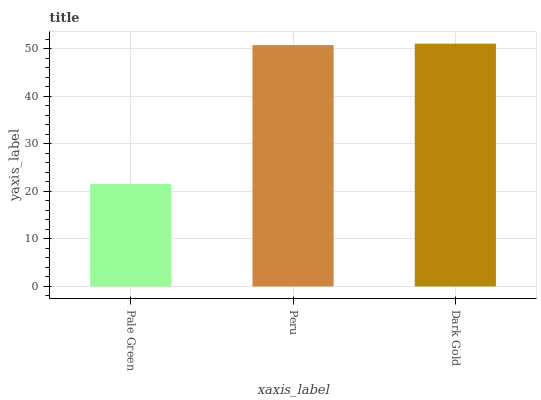Is Peru the minimum?
Answer yes or no. No. Is Peru the maximum?
Answer yes or no. No. Is Peru greater than Pale Green?
Answer yes or no. Yes. Is Pale Green less than Peru?
Answer yes or no. Yes. Is Pale Green greater than Peru?
Answer yes or no. No. Is Peru less than Pale Green?
Answer yes or no. No. Is Peru the high median?
Answer yes or no. Yes. Is Peru the low median?
Answer yes or no. Yes. Is Dark Gold the high median?
Answer yes or no. No. Is Dark Gold the low median?
Answer yes or no. No. 